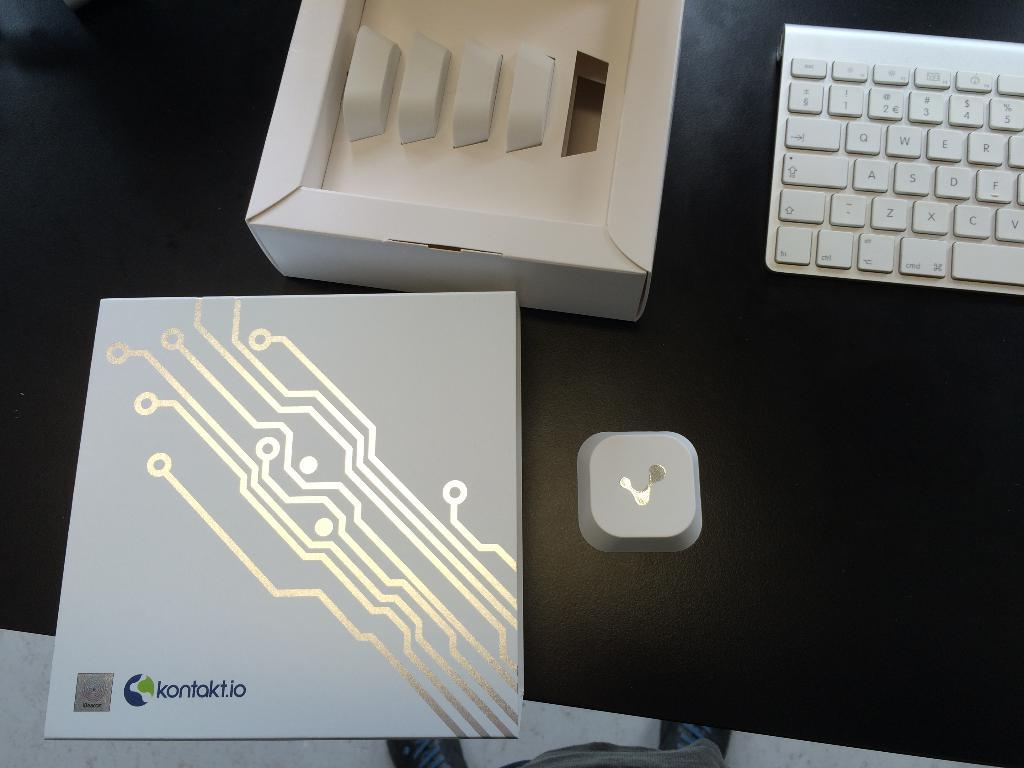<image>
Summarize the visual content of the image. The keyboard was made by the name Kontak.io 